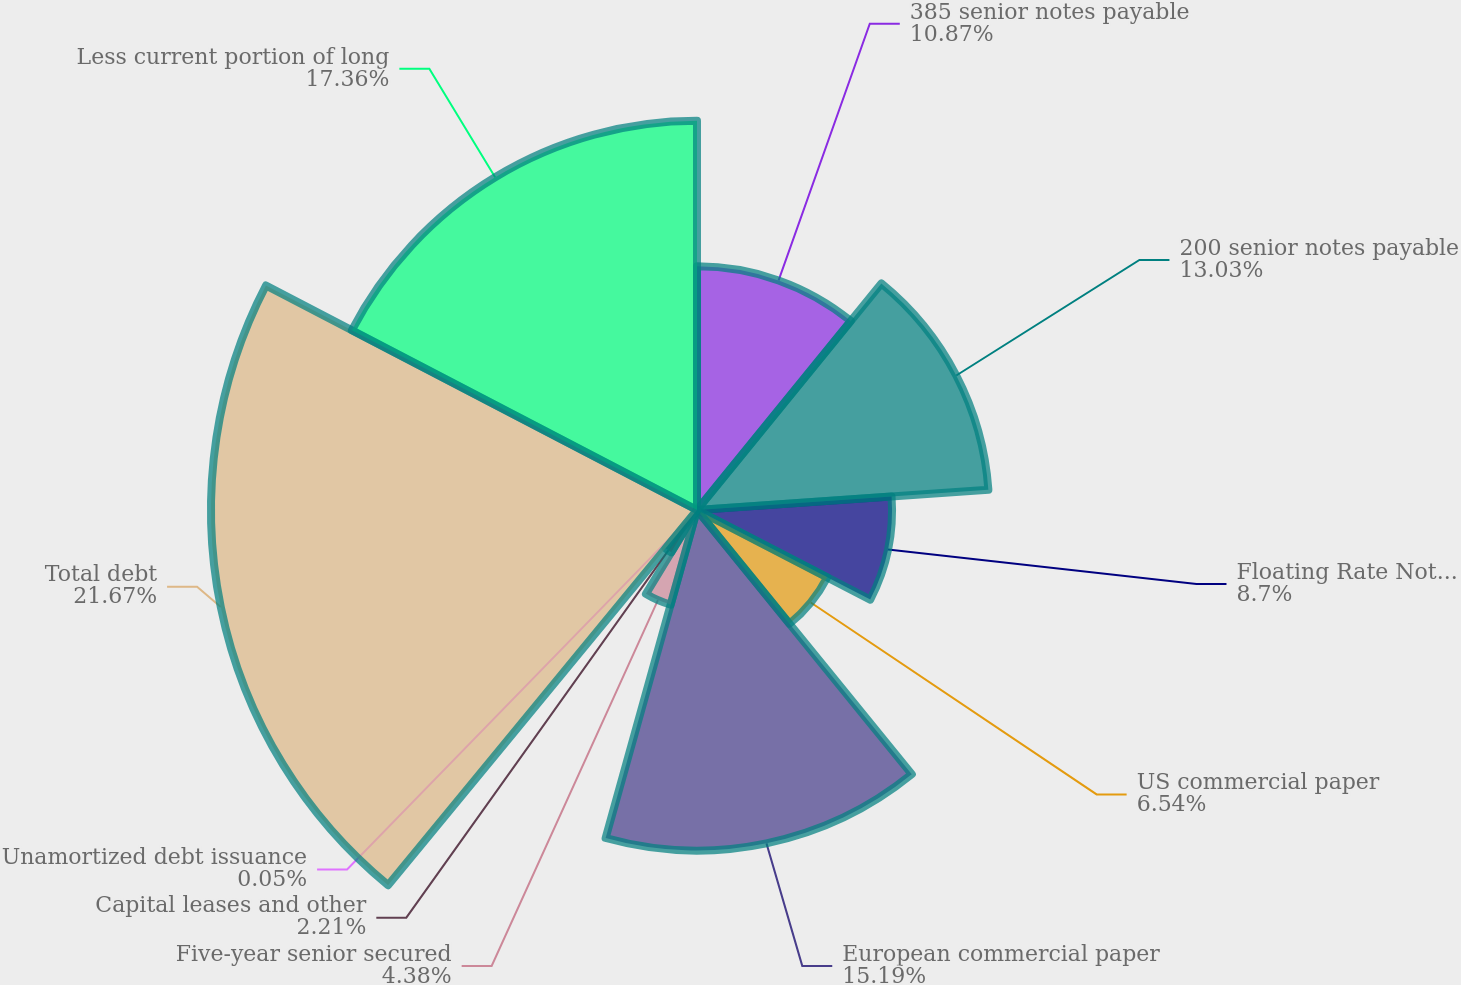Convert chart to OTSL. <chart><loc_0><loc_0><loc_500><loc_500><pie_chart><fcel>385 senior notes payable<fcel>200 senior notes payable<fcel>Floating Rate Notes payable<fcel>US commercial paper<fcel>European commercial paper<fcel>Five-year senior secured<fcel>Capital leases and other<fcel>Unamortized debt issuance<fcel>Total debt<fcel>Less current portion of long<nl><fcel>10.87%<fcel>13.03%<fcel>8.7%<fcel>6.54%<fcel>15.19%<fcel>4.38%<fcel>2.21%<fcel>0.05%<fcel>21.68%<fcel>17.36%<nl></chart> 